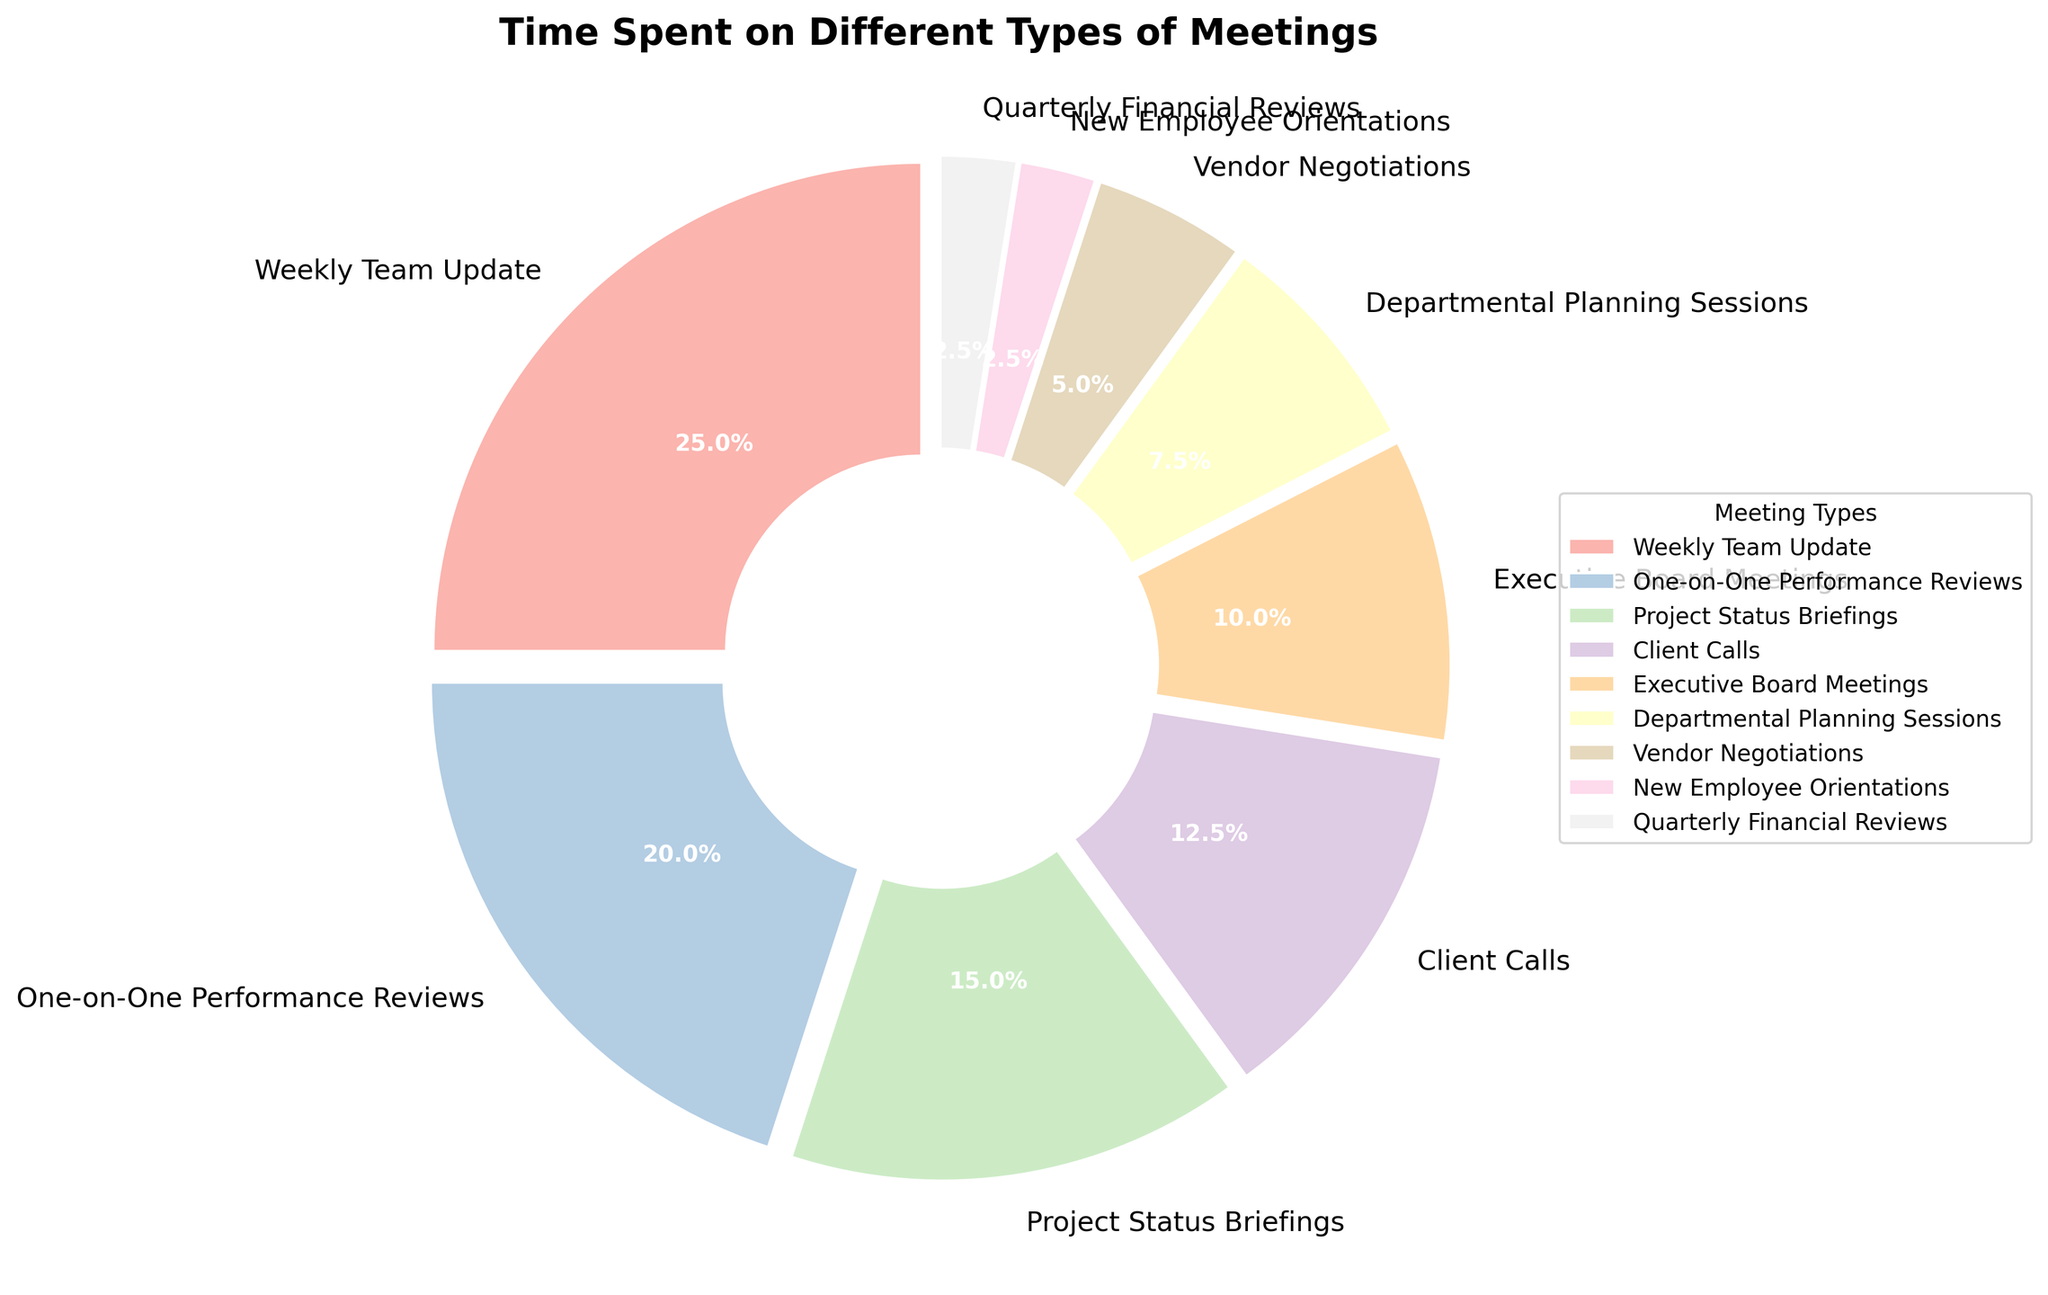Which meeting type occupies the largest portion of time? Inspect the pie chart for the segment that appears the largest and has the highest percentage value. In this case, "Weekly Team Update" appears the most substantial with 5 hours.
Answer: Weekly Team Update Which two meeting types together take up the largest portion of the pie? Identify the two segments that, when summed, account for the largest portion. The "Weekly Team Update" (5 hours) and "One-on-One Performance Reviews" (4 hours) together take up 9 hours.
Answer: Weekly Team Update and One-on-One Performance Reviews How much time is spent on Client Calls compared to Executive Board Meetings? Find the segments labeled "Client Calls" and "Executive Board Meetings" and compare the hours. "Client Calls" is 2.5 hours, and "Executive Board Meetings" is 2 hours.
Answer: Client Calls spend 0.5 hours more What is the total time spent on New Employee Orientations and Quarterly Financial Reviews? Add the hours for "New Employee Orientations" (0.5 hours) and "Quarterly Financial Reviews" (0.5 hours). 0.5 + 0.5 = 1 hour.
Answer: 1 hour Which meeting type uses exactly double the time of Vendor Negotiations? Identify which segment's hours are twice that of "Vendor Negotiations" (1 hour). "One-on-One Performance Reviews" has 4 hours, which is not double; "Project Status Briefings" has 3 hours, which is not double. "Executive Board Meetings" has 2 hours, which is exactly double.
Answer: Executive Board Meetings Are there any meeting types that take up exactly the same amount of time? Check for segments with identical percentage values and hours. "New Employee Orientations" (0.5 hours) and "Quarterly Financial Reviews" (0.5 hours) are the same.
Answer: New Employee Orientations and Quarterly Financial Reviews What is the difference in time spent between the Departmental Planning Sessions and Vendor Negotiations? Subtract the time for "Vendor Negotiations" (1 hour) from "Departmental Planning Sessions" (1.5 hours). 1.5 - 1 = 0.5 hours.
Answer: 0.5 hours What percentage of total time is spent on meetings that take up more than 2 hours each? Calculate the percentage for each meeting type above 2 hours: "Weekly Team Update" (5 hours), "One-on-One Performance Reviews" (4 hours), "Project Status Briefings" (3 hours), and "Client Calls" (2.5 hours). Sum the percentages: 16.1% + 12.9% + 9.7% + 8.1% = 46.8%.
Answer: 46.8% What is the average time spent on One-on-One Performance Reviews, Project Status Briefings, and Client Calls? Add the hours for these meetings: 4 (One-on-One Performance Reviews) + 3 (Project Status Briefings) + 2.5 (Client Calls) = 9.5 hours, and then divide by 3. 9.5 / 3 ≈ 3.17 hours.
Answer: Approximately 3.17 hours 